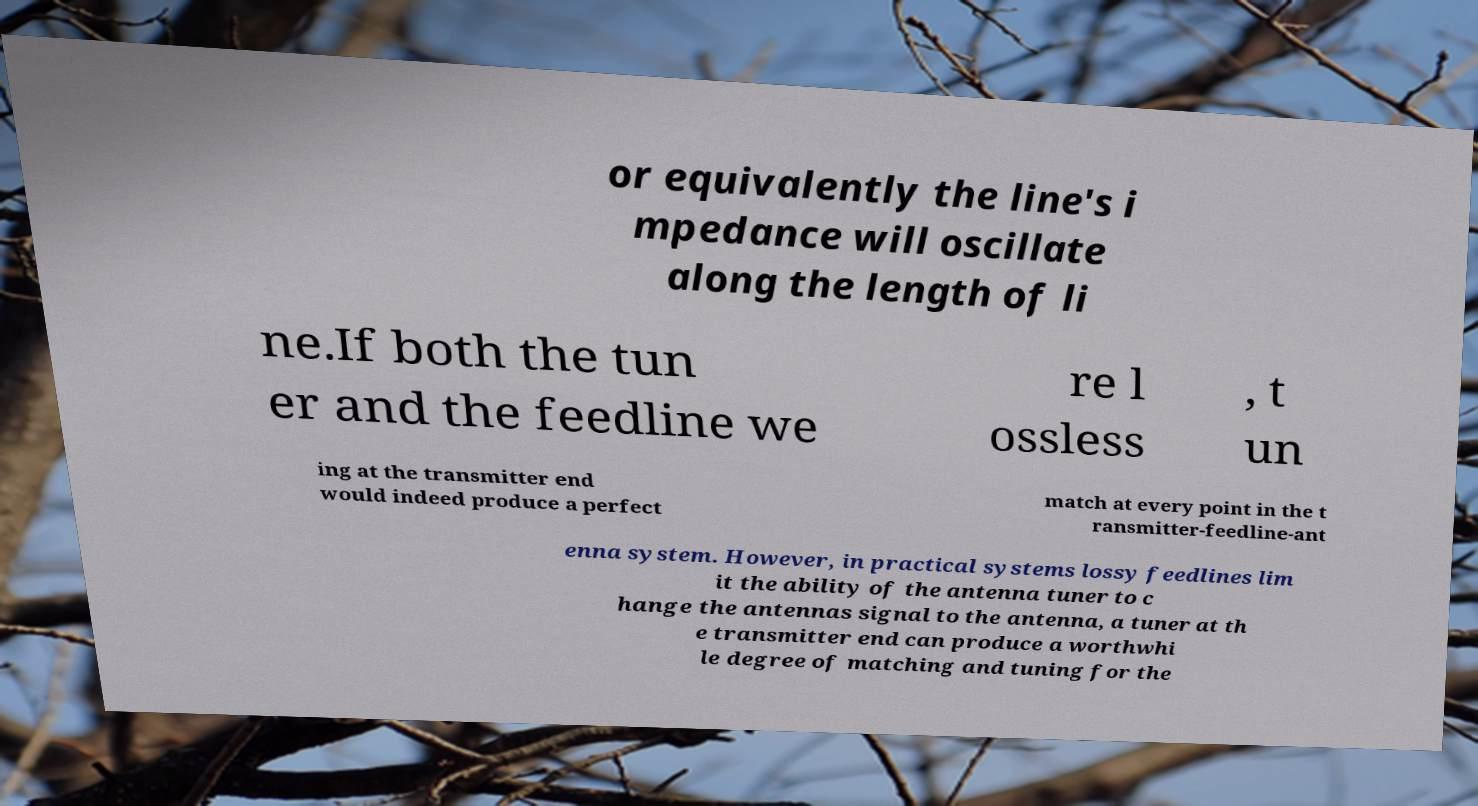I need the written content from this picture converted into text. Can you do that? or equivalently the line's i mpedance will oscillate along the length of li ne.If both the tun er and the feedline we re l ossless , t un ing at the transmitter end would indeed produce a perfect match at every point in the t ransmitter-feedline-ant enna system. However, in practical systems lossy feedlines lim it the ability of the antenna tuner to c hange the antennas signal to the antenna, a tuner at th e transmitter end can produce a worthwhi le degree of matching and tuning for the 